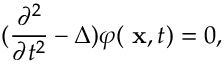Convert formula to latex. <formula><loc_0><loc_0><loc_500><loc_500>( \frac { \partial ^ { 2 } } { \partial t ^ { 2 } } - \Delta ) \varphi ( x , t ) = 0 ,</formula> 